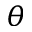Convert formula to latex. <formula><loc_0><loc_0><loc_500><loc_500>\theta</formula> 